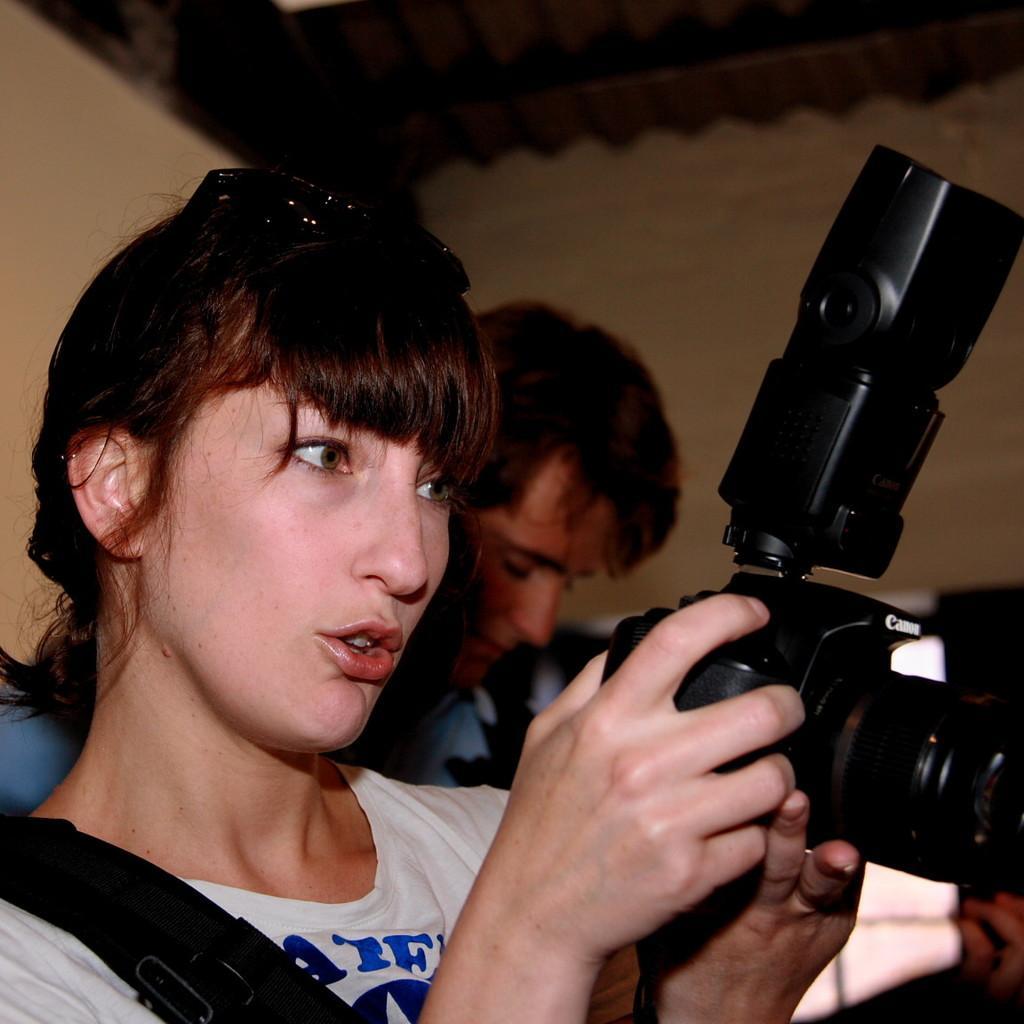Describe this image in one or two sentences. a person is standing wearing a white t shirt. holding a camera in her hand. behind her a person is standing. at the back there's a wall. 